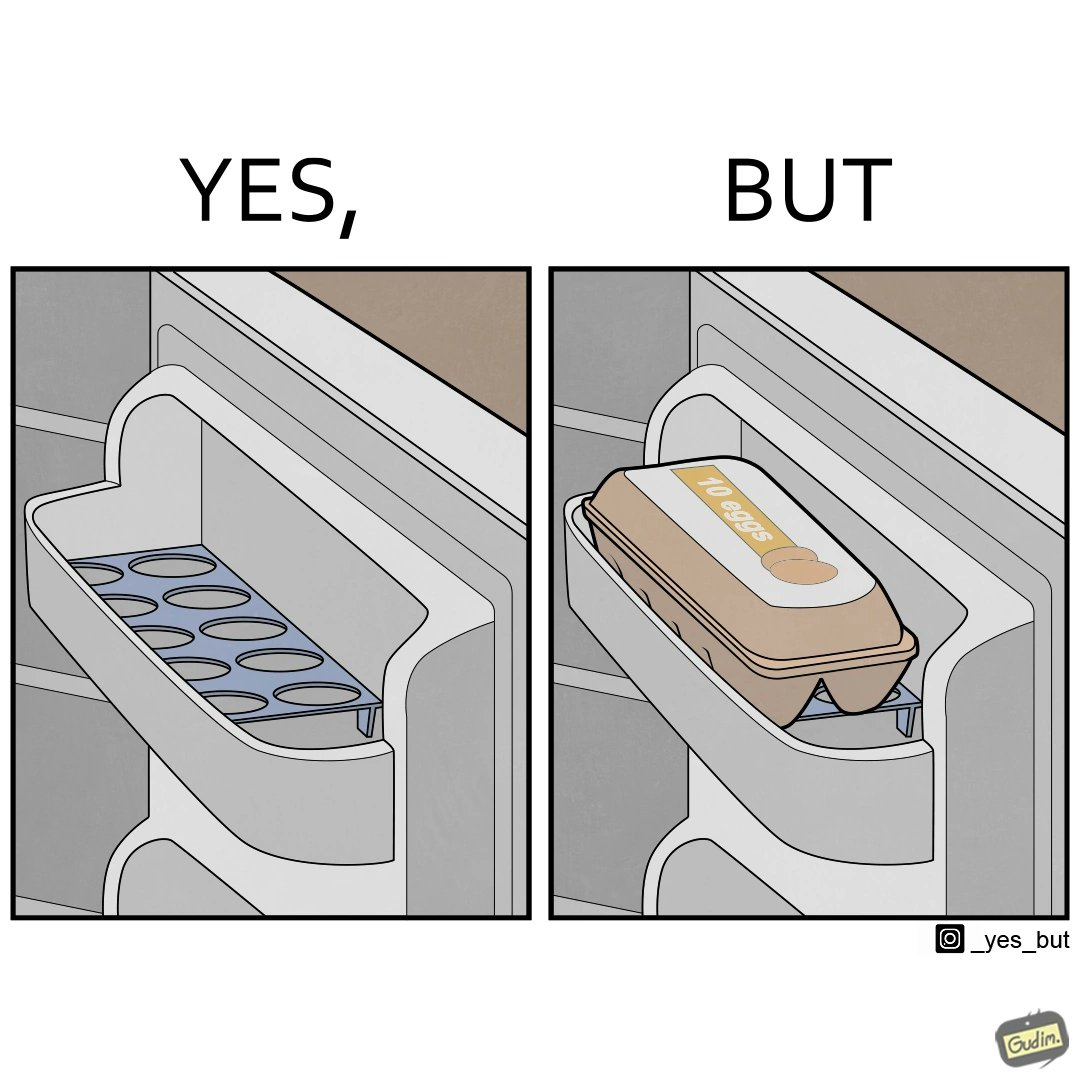Is this a satirical image? Yes, this image is satirical. 